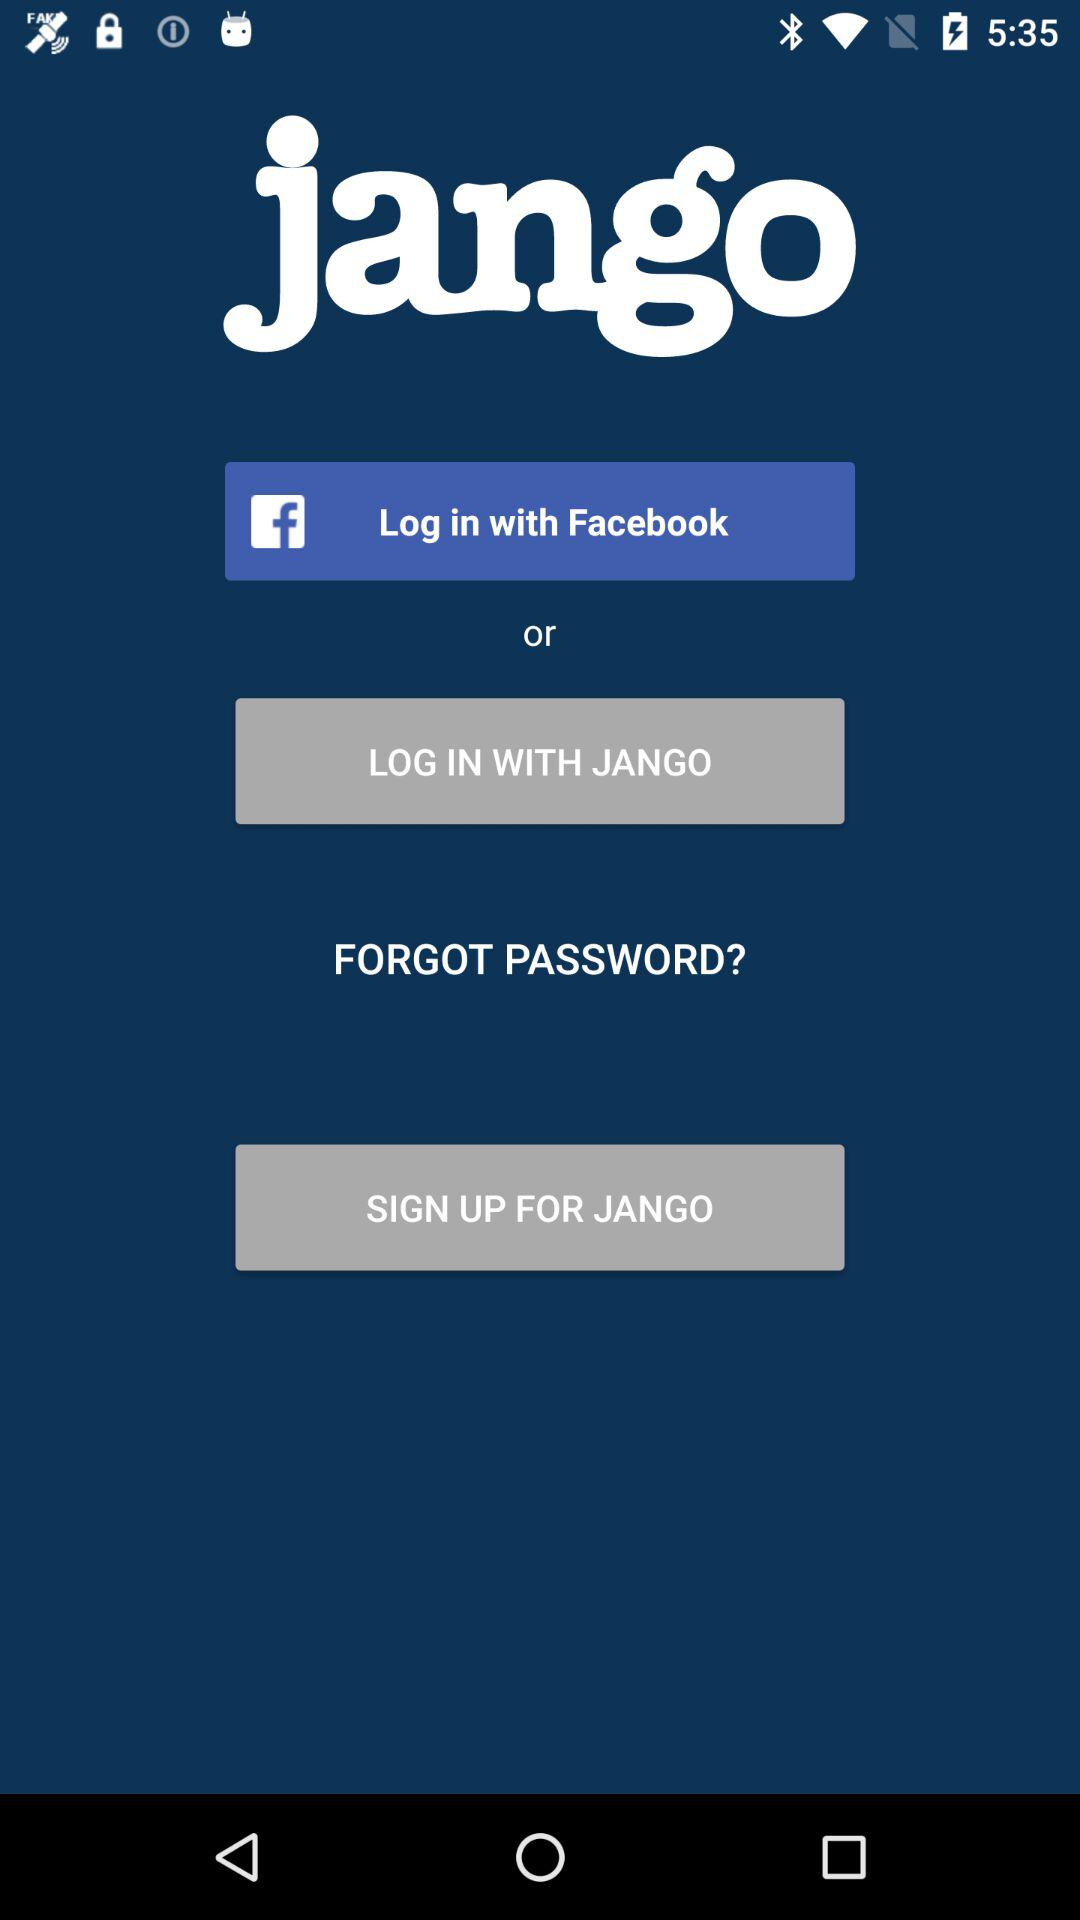Which application can be used to log in? The applications "Facebook" and "JANGO" can be used to log in. 